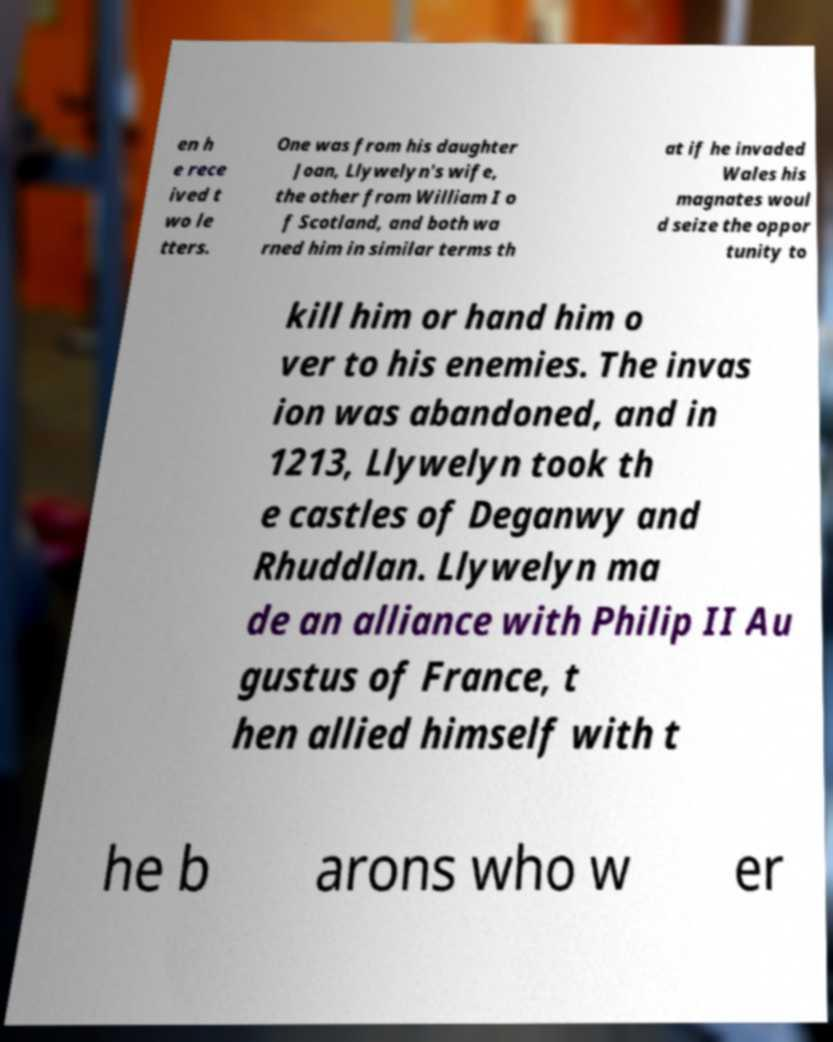Please identify and transcribe the text found in this image. en h e rece ived t wo le tters. One was from his daughter Joan, Llywelyn's wife, the other from William I o f Scotland, and both wa rned him in similar terms th at if he invaded Wales his magnates woul d seize the oppor tunity to kill him or hand him o ver to his enemies. The invas ion was abandoned, and in 1213, Llywelyn took th e castles of Deganwy and Rhuddlan. Llywelyn ma de an alliance with Philip II Au gustus of France, t hen allied himself with t he b arons who w er 